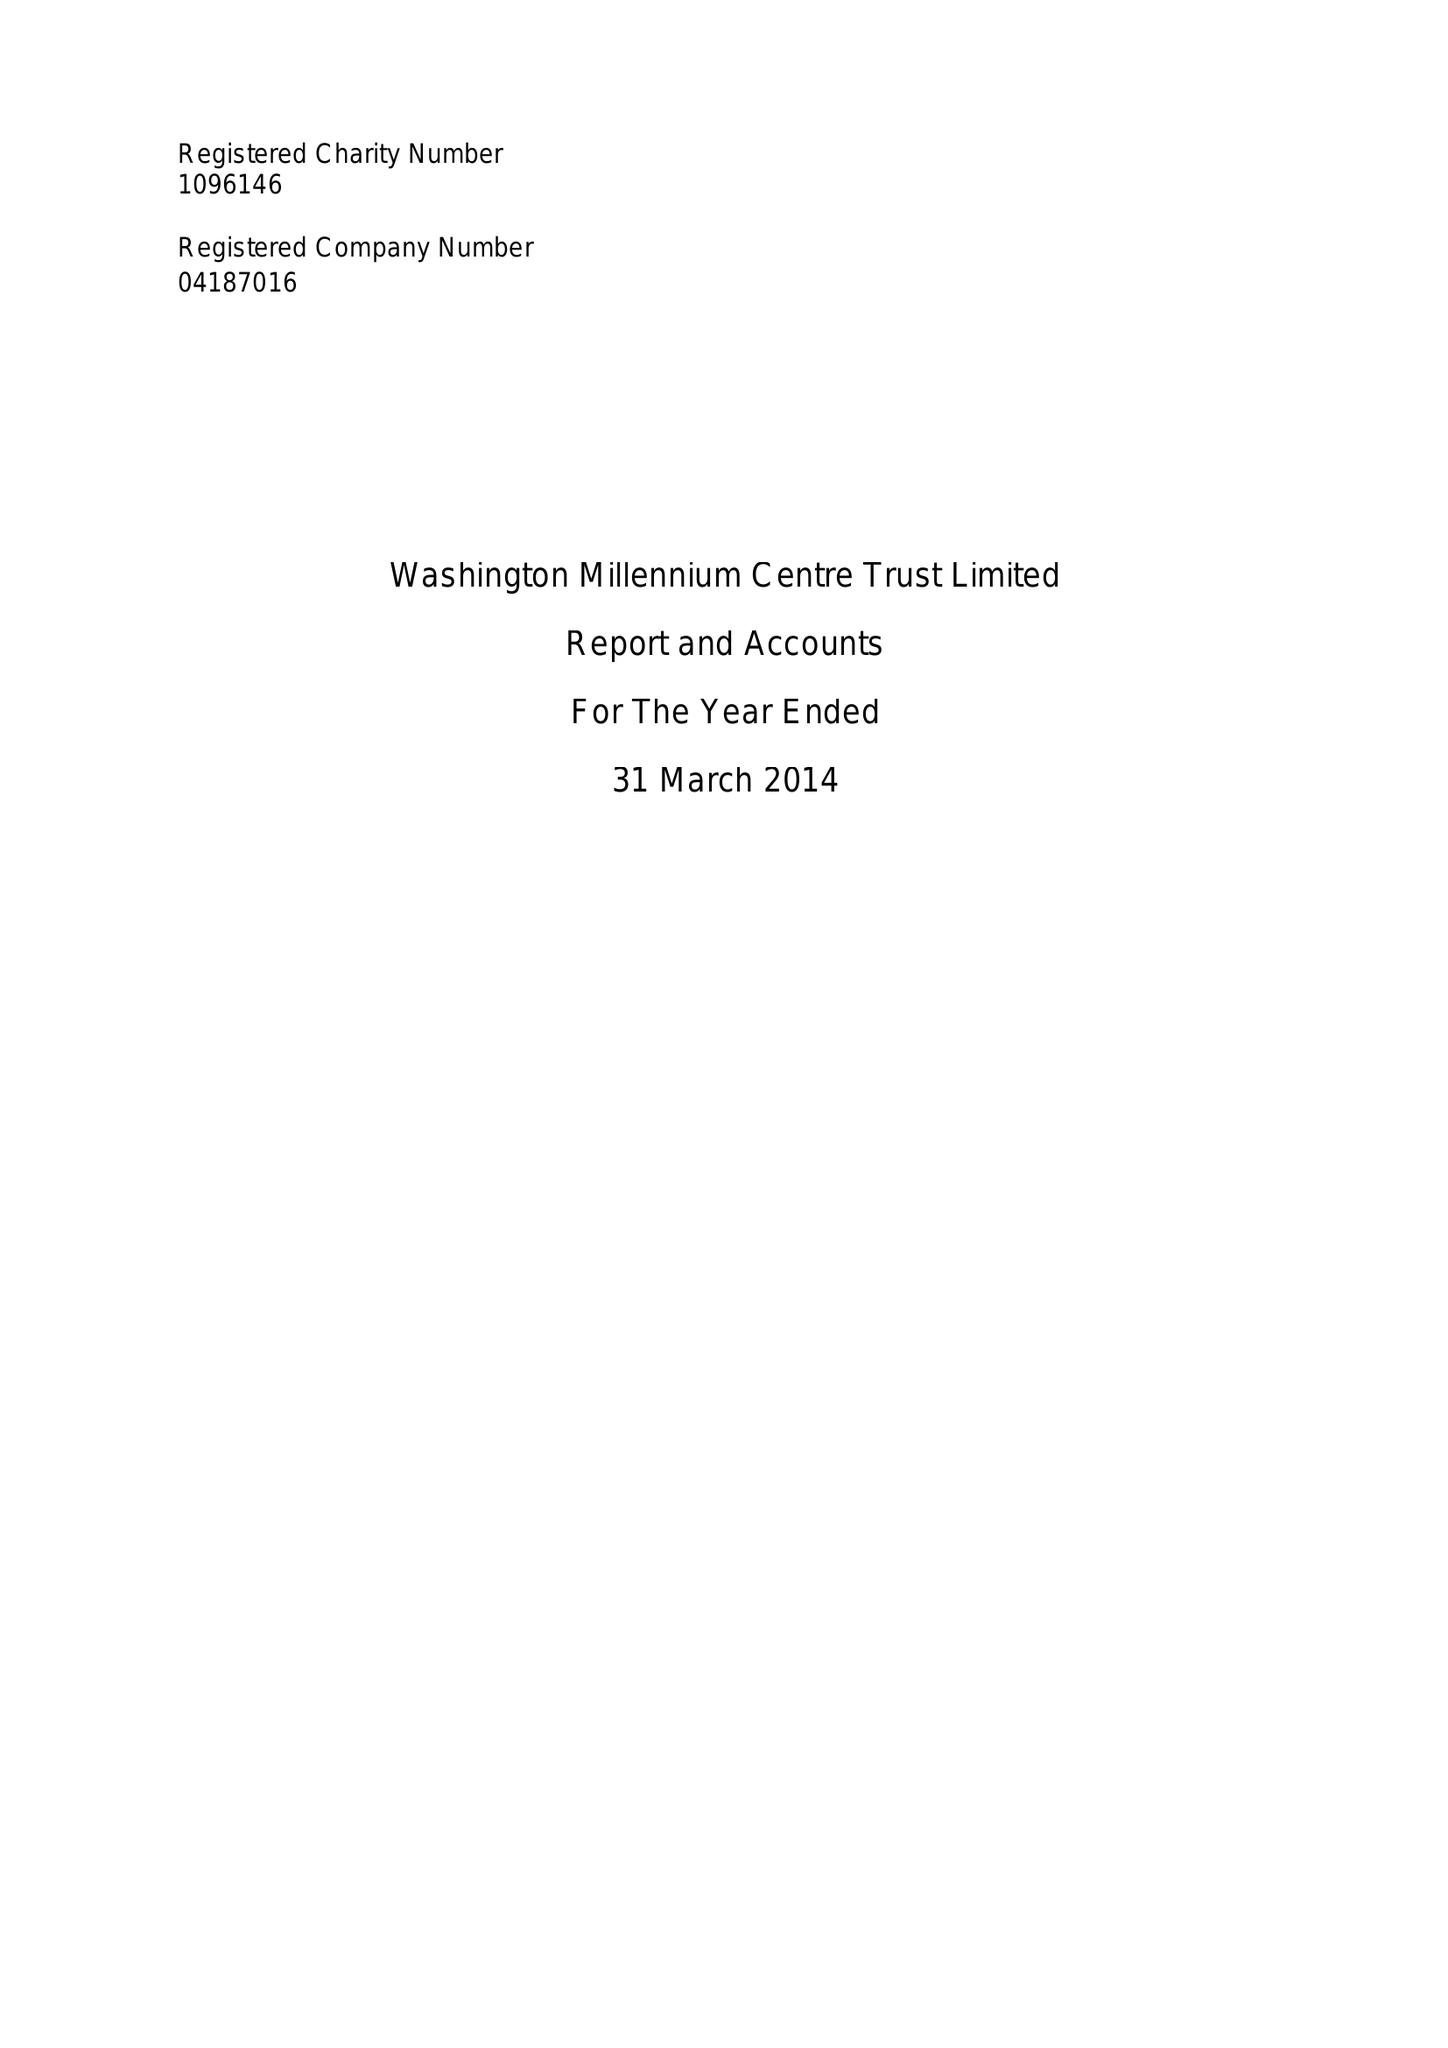What is the value for the address__postcode?
Answer the question using a single word or phrase. NE37 2QD 